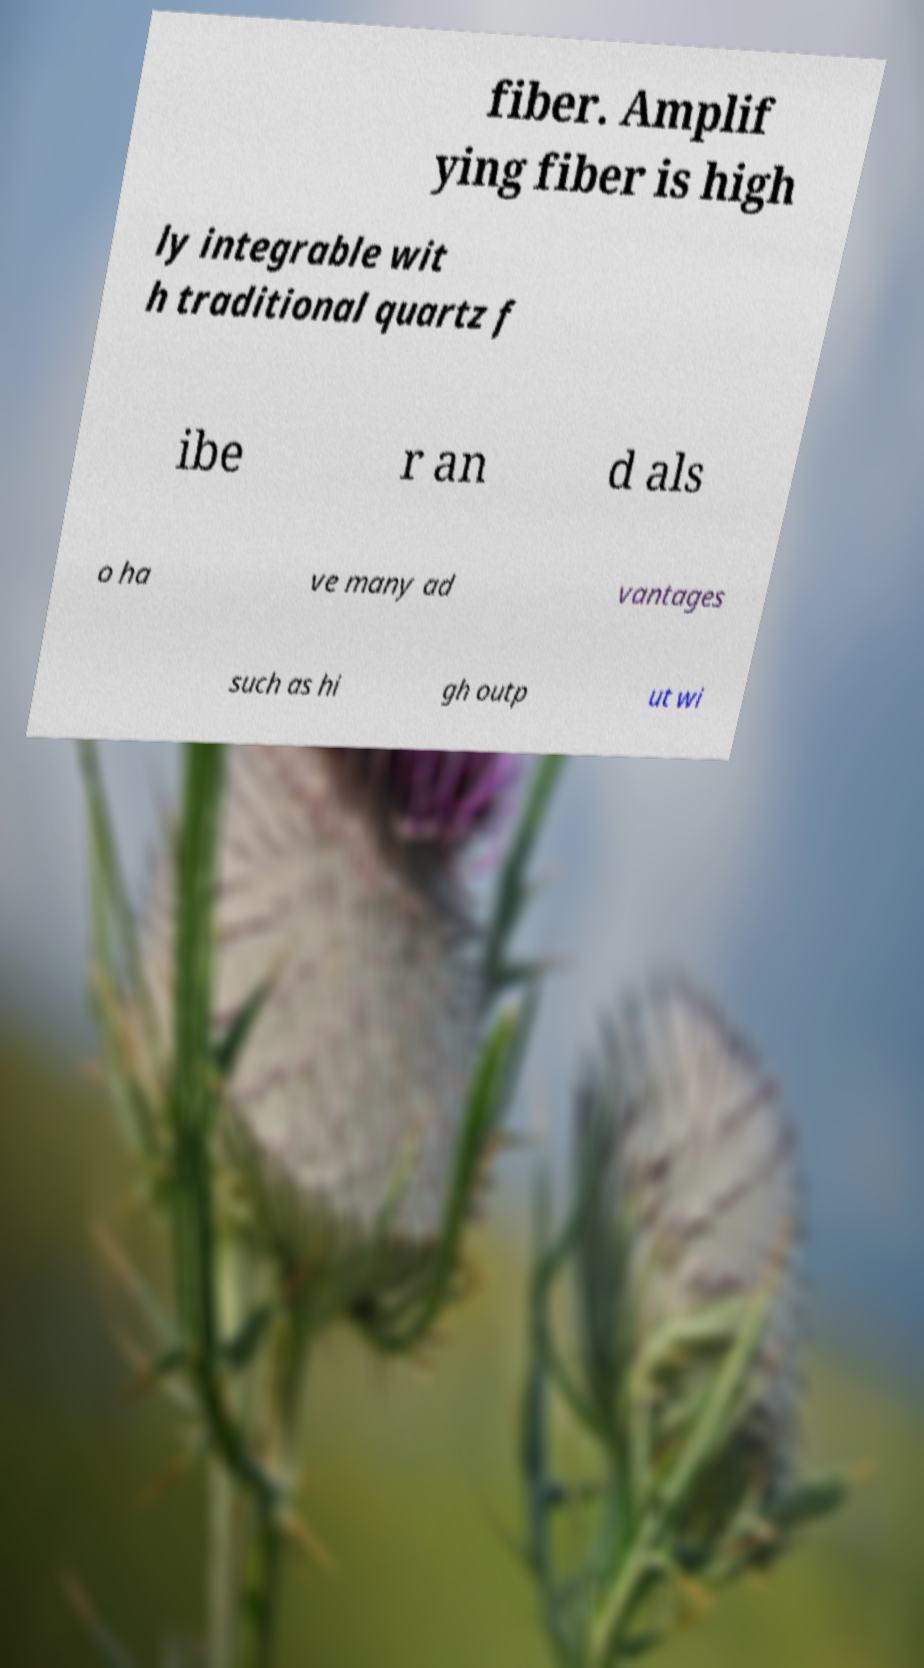I need the written content from this picture converted into text. Can you do that? fiber. Amplif ying fiber is high ly integrable wit h traditional quartz f ibe r an d als o ha ve many ad vantages such as hi gh outp ut wi 